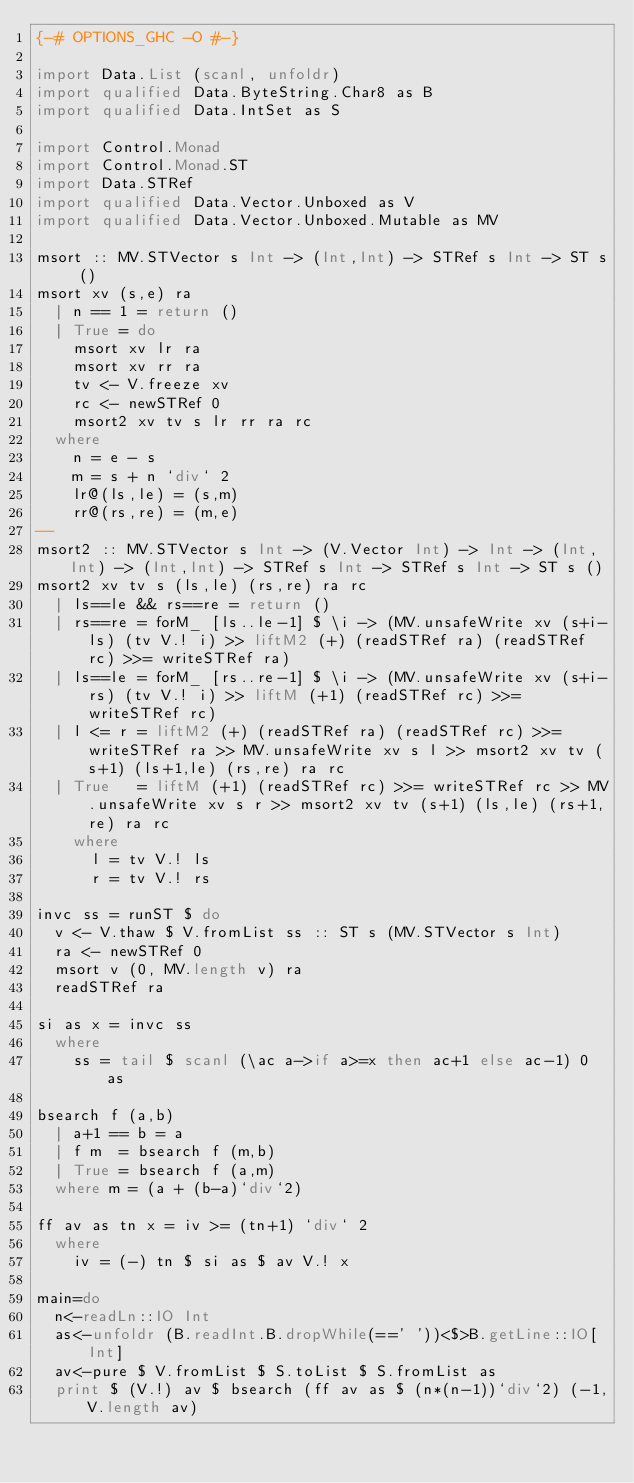Convert code to text. <code><loc_0><loc_0><loc_500><loc_500><_Haskell_>{-# OPTIONS_GHC -O #-}

import Data.List (scanl, unfoldr)
import qualified Data.ByteString.Char8 as B
import qualified Data.IntSet as S

import Control.Monad
import Control.Monad.ST
import Data.STRef
import qualified Data.Vector.Unboxed as V
import qualified Data.Vector.Unboxed.Mutable as MV

msort :: MV.STVector s Int -> (Int,Int) -> STRef s Int -> ST s ()
msort xv (s,e) ra
  | n == 1 = return ()
  | True = do
    msort xv lr ra
    msort xv rr ra
    tv <- V.freeze xv
    rc <- newSTRef 0
    msort2 xv tv s lr rr ra rc
  where
    n = e - s
    m = s + n `div` 2
    lr@(ls,le) = (s,m)
    rr@(rs,re) = (m,e)
--
msort2 :: MV.STVector s Int -> (V.Vector Int) -> Int -> (Int,Int) -> (Int,Int) -> STRef s Int -> STRef s Int -> ST s ()
msort2 xv tv s (ls,le) (rs,re) ra rc
  | ls==le && rs==re = return ()
  | rs==re = forM_ [ls..le-1] $ \i -> (MV.unsafeWrite xv (s+i-ls) (tv V.! i) >> liftM2 (+) (readSTRef ra) (readSTRef rc) >>= writeSTRef ra)
  | ls==le = forM_ [rs..re-1] $ \i -> (MV.unsafeWrite xv (s+i-rs) (tv V.! i) >> liftM (+1) (readSTRef rc) >>= writeSTRef rc)
  | l <= r = liftM2 (+) (readSTRef ra) (readSTRef rc) >>= writeSTRef ra >> MV.unsafeWrite xv s l >> msort2 xv tv (s+1) (ls+1,le) (rs,re) ra rc
  | True   = liftM (+1) (readSTRef rc) >>= writeSTRef rc >> MV.unsafeWrite xv s r >> msort2 xv tv (s+1) (ls,le) (rs+1,re) ra rc
    where
      l = tv V.! ls
      r = tv V.! rs

invc ss = runST $ do
  v <- V.thaw $ V.fromList ss :: ST s (MV.STVector s Int)
  ra <- newSTRef 0
  msort v (0, MV.length v) ra
  readSTRef ra

si as x = invc ss
  where
    ss = tail $ scanl (\ac a->if a>=x then ac+1 else ac-1) 0 as

bsearch f (a,b)
  | a+1 == b = a
  | f m  = bsearch f (m,b)
  | True = bsearch f (a,m)
  where m = (a + (b-a)`div`2)

ff av as tn x = iv >= (tn+1) `div` 2
  where
    iv = (-) tn $ si as $ av V.! x

main=do
  n<-readLn::IO Int
  as<-unfoldr (B.readInt.B.dropWhile(==' '))<$>B.getLine::IO[Int]
  av<-pure $ V.fromList $ S.toList $ S.fromList as
  print $ (V.!) av $ bsearch (ff av as $ (n*(n-1))`div`2) (-1,V.length av)</code> 